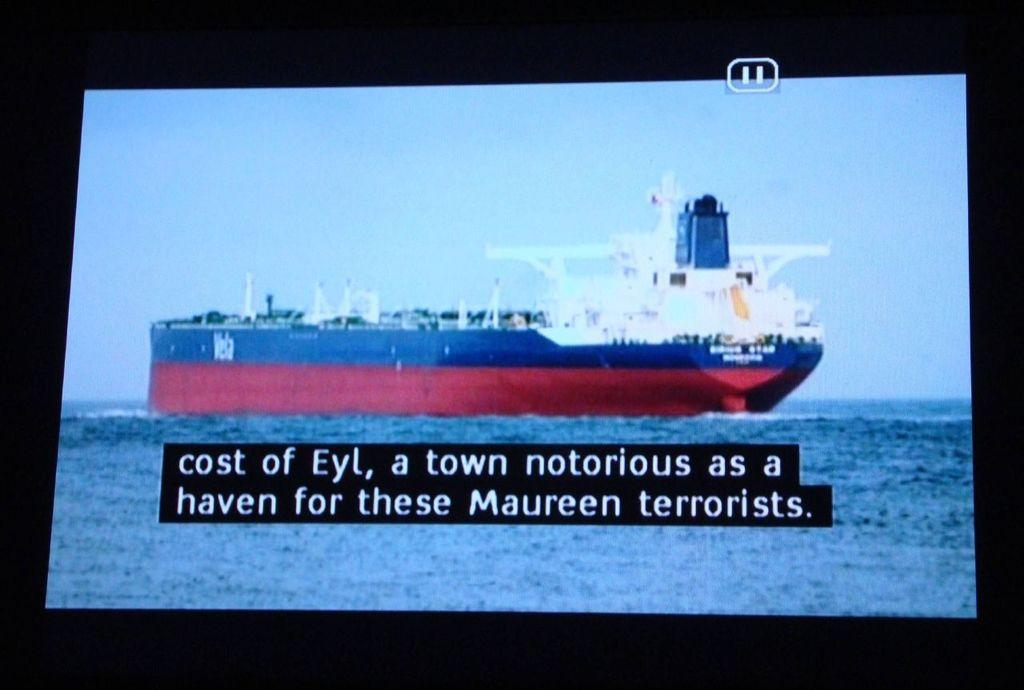<image>
Describe the image concisely. A boat traveling through water is on a television screen as the captions explain that a nearby town is known for being a home to terrorist. 